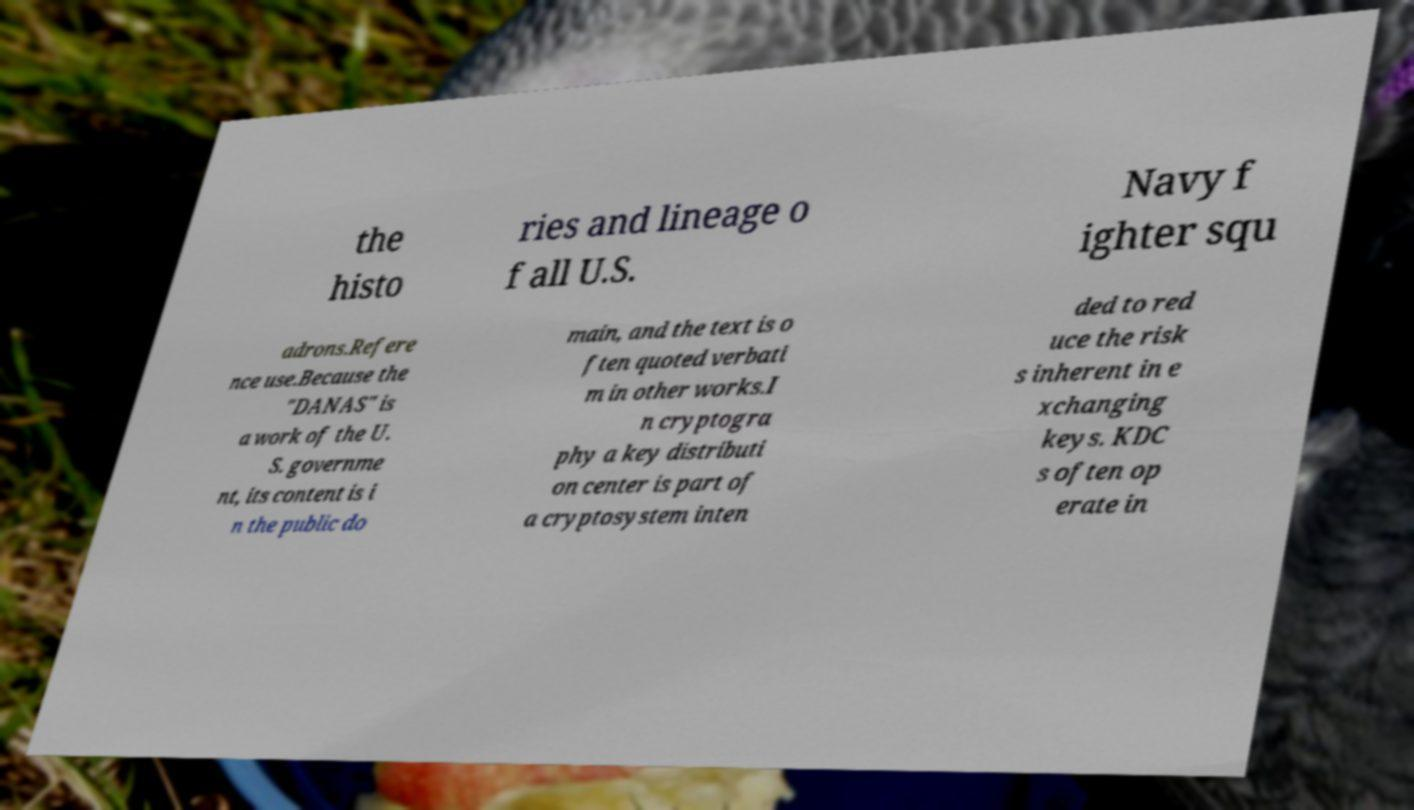How are historical military documents like the one in the image typically used? Historical military documents serve various purposes, such as educational resources, research materials for historians, and insights into military strategy and development. They offer a detailed record of military events, personnel, equipment, and decision-making processes. In addition, such documents can contribute to preserving institutional memory and fostering a sense of heritage and identity within military organizations. Why might this document mention a cryptographic key distribution center? Though the context is not entirely clear from the image, the mention of a Key Distribution Center (KDC) may suggest that the document touches on matters of military communication security. KDCs are critical in managing the distribution of cryptographic keys that secure communication systems, which are essential for maintaining operational secrecy and integrity within the military. 